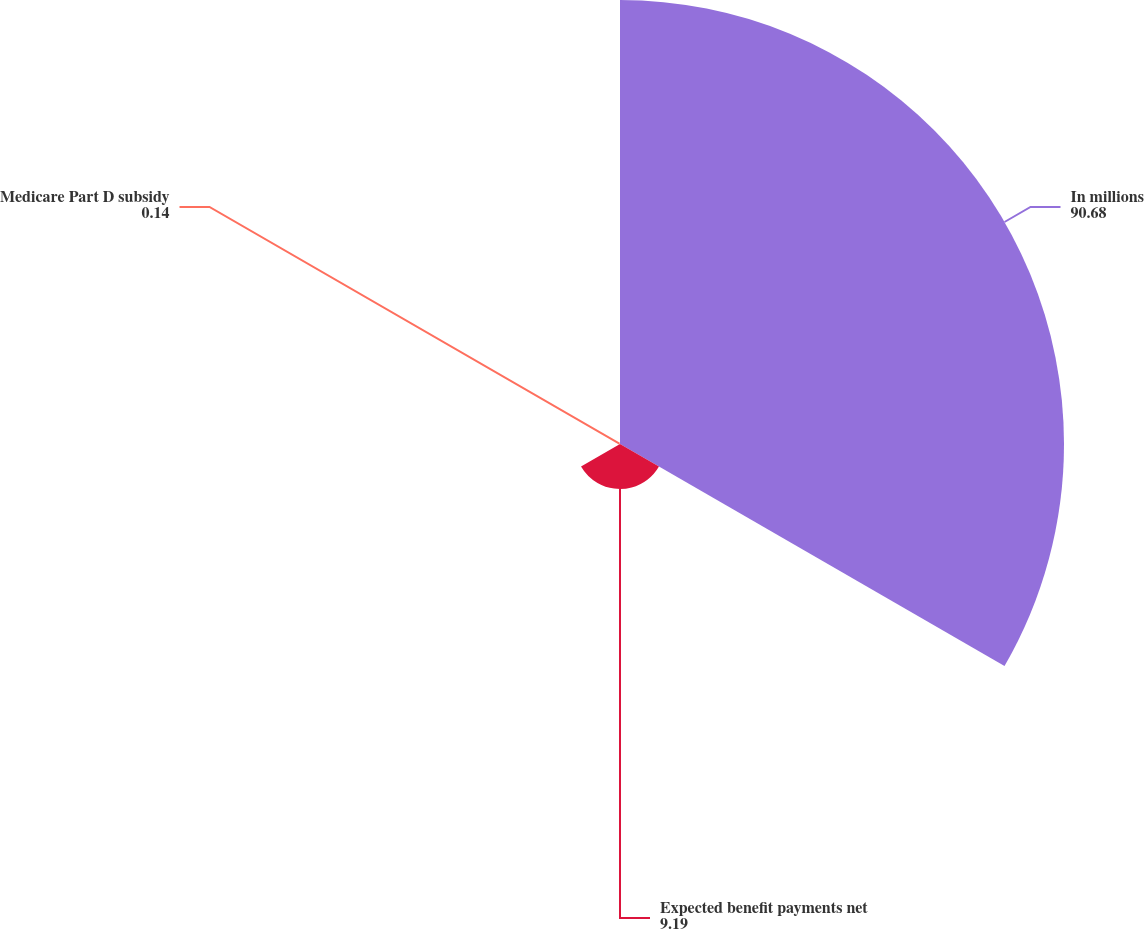Convert chart. <chart><loc_0><loc_0><loc_500><loc_500><pie_chart><fcel>In millions<fcel>Expected benefit payments net<fcel>Medicare Part D subsidy<nl><fcel>90.68%<fcel>9.19%<fcel>0.14%<nl></chart> 